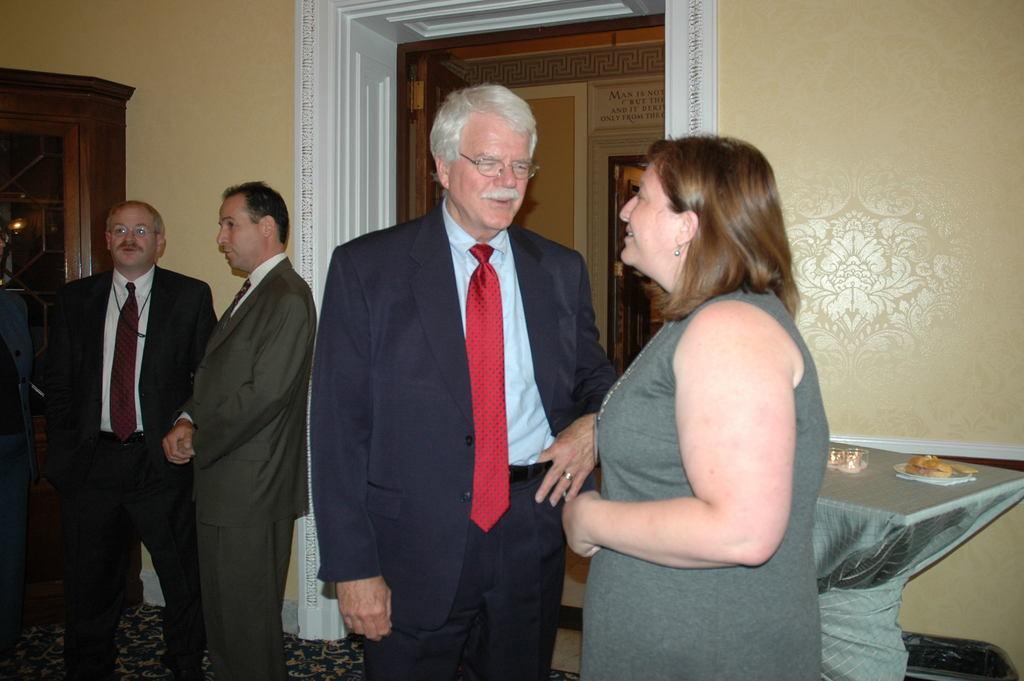In one or two sentences, can you explain what this image depicts? In this picture we can see some people are standing and talking, side we can see the table on which we can see some things are placed, behind we can see a door to the wall. 